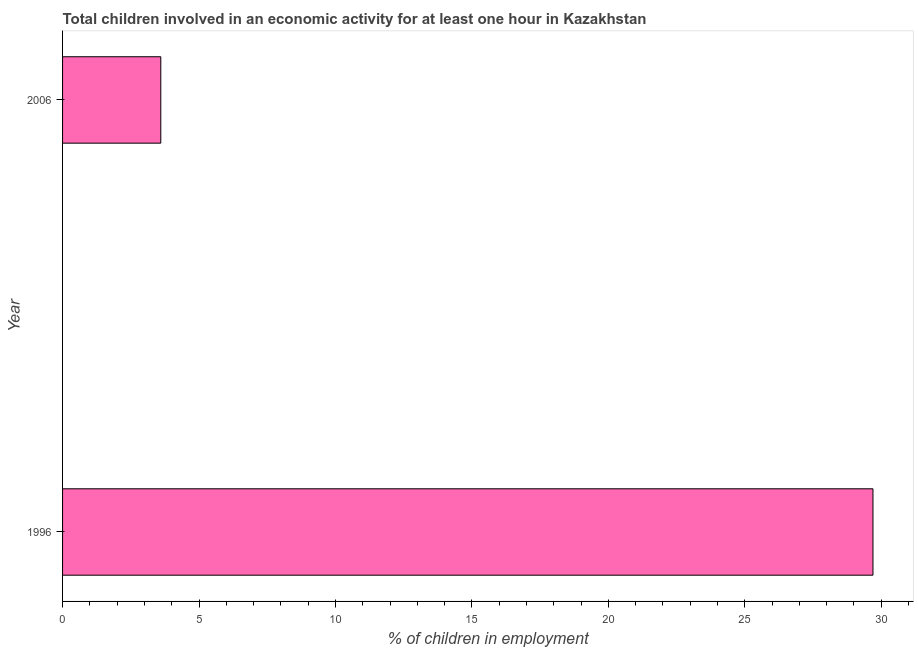Does the graph contain grids?
Provide a short and direct response. No. What is the title of the graph?
Your answer should be compact. Total children involved in an economic activity for at least one hour in Kazakhstan. What is the label or title of the X-axis?
Your response must be concise. % of children in employment. What is the percentage of children in employment in 2006?
Provide a succinct answer. 3.6. Across all years, what is the maximum percentage of children in employment?
Ensure brevity in your answer.  29.7. Across all years, what is the minimum percentage of children in employment?
Give a very brief answer. 3.6. In which year was the percentage of children in employment maximum?
Your response must be concise. 1996. In which year was the percentage of children in employment minimum?
Your response must be concise. 2006. What is the sum of the percentage of children in employment?
Offer a very short reply. 33.3. What is the difference between the percentage of children in employment in 1996 and 2006?
Your answer should be very brief. 26.1. What is the average percentage of children in employment per year?
Give a very brief answer. 16.65. What is the median percentage of children in employment?
Ensure brevity in your answer.  16.65. What is the ratio of the percentage of children in employment in 1996 to that in 2006?
Keep it short and to the point. 8.25. Is the percentage of children in employment in 1996 less than that in 2006?
Provide a short and direct response. No. In how many years, is the percentage of children in employment greater than the average percentage of children in employment taken over all years?
Offer a very short reply. 1. How many years are there in the graph?
Your answer should be compact. 2. What is the % of children in employment of 1996?
Ensure brevity in your answer.  29.7. What is the difference between the % of children in employment in 1996 and 2006?
Keep it short and to the point. 26.1. What is the ratio of the % of children in employment in 1996 to that in 2006?
Make the answer very short. 8.25. 